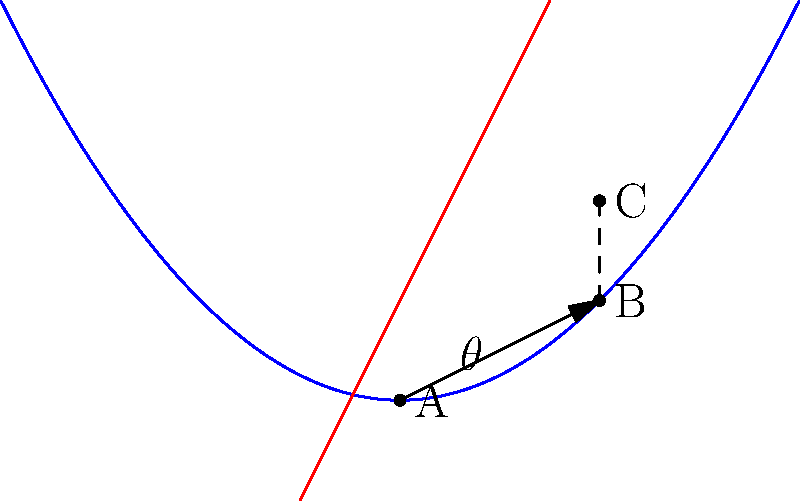A predator is pursuing prey along a parabolic trajectory defined by $y = 0.25x^2$. At point B(2, 1), the predator changes its course to intercept the prey at point C(2, 2). Given that the predator's initial position is at point A(0, 0), determine the angle of deflection $\theta$ (in degrees) that the predator must make to successfully intercept the prey. To solve this problem, we'll follow these steps:

1) First, we need to find the slope of the predator's initial path (AB):
   Slope of AB = $\frac{y_B - y_A}{x_B - x_A} = \frac{1 - 0}{2 - 0} = \frac{1}{2}$

2) The angle this path makes with the x-axis is:
   $\theta_1 = \tan^{-1}(\frac{1}{2}) \approx 26.57°$

3) Now, we need to find the slope of the new path (BC):
   Slope of BC = $\frac{y_C - y_B}{x_C - x_B} = \frac{2 - 1}{2 - 2} = \infty$
   This means BC is vertical.

4) The angle BC makes with the x-axis is 90°.

5) The angle of deflection $\theta$ is the difference between these angles:
   $\theta = 90° - 26.57° = 63.43°$

6) Rounding to two decimal places:
   $\theta \approx 63.43°$
Answer: $63.43°$ 